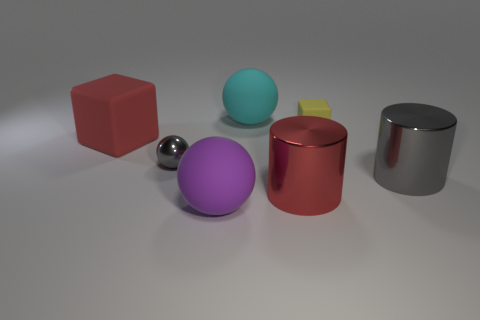There is another shiny object that is the same size as the red shiny thing; what is its color?
Provide a succinct answer. Gray. Is there a cylinder of the same color as the big matte cube?
Your answer should be compact. Yes. How many things are either purple rubber objects or yellow objects?
Offer a terse response. 2. There is a yellow matte cube; is its size the same as the metallic object right of the yellow cube?
Give a very brief answer. No. There is a shiny object that is on the right side of the rubber cube to the right of the big rubber sphere that is in front of the small block; what color is it?
Provide a succinct answer. Gray. The tiny metal ball is what color?
Your response must be concise. Gray. Is the number of small shiny objects to the right of the tiny gray metallic object greater than the number of big gray metal objects left of the small yellow rubber block?
Your answer should be very brief. No. Is the shape of the large purple thing the same as the gray object that is in front of the small gray metallic object?
Offer a very short reply. No. Is the size of the rubber ball behind the gray metal ball the same as the cylinder that is to the right of the small matte block?
Make the answer very short. Yes. Are there any purple rubber things that are to the right of the large red matte cube that is to the left of the small thing that is on the left side of the small yellow rubber object?
Give a very brief answer. Yes. 